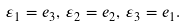<formula> <loc_0><loc_0><loc_500><loc_500>\varepsilon _ { 1 } = e _ { 3 } , \, \varepsilon _ { 2 } = e _ { 2 } , \, \varepsilon _ { 3 } = e _ { 1 } .</formula> 